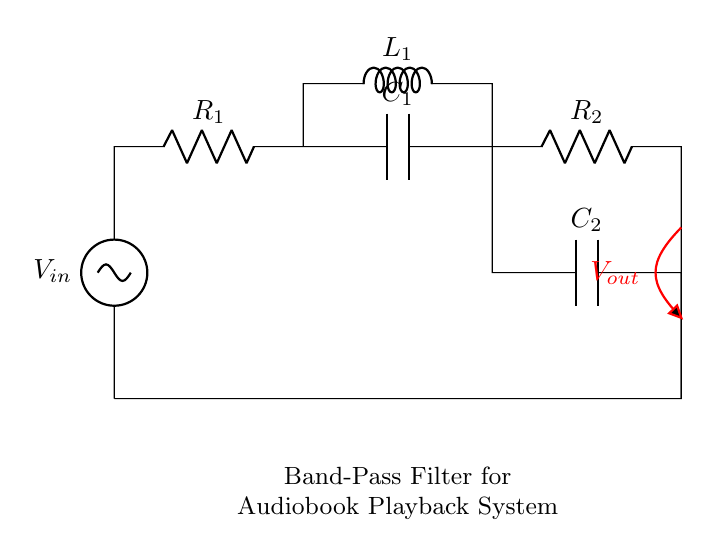What is the input voltage of the circuit? The input voltage is denoted as V_in in the circuit, which indicates the voltage supplied to the circuit.
Answer: V_in What components are connected in series with V_in? V_in is connected in series with a resistor R_1, a capacitor C_1, and a resistor R_2. These components are arranged one after the other along the same path.
Answer: R_1, C_1, R_2 Which component is connected parallel to C_1? The inductor L_1 is connected in parallel to the capacitor C_1, as indicated by the connections that allow current to flow through both elements simultaneously.
Answer: L_1 What is the purpose of this band-pass filter? The band-pass filter is designed to isolate specific frequency ranges, allowing signals within that range to pass while attenuating others, making it effective for audio applications.
Answer: Isolate specific frequency ranges What determines the center frequency of this filter? The center frequency is determined by the values of the inductor L_1 and capacitors C_1 and C_2, as these components define the filter's resonance and frequency response characteristics.
Answer: Inductor L_1 and capacitors C_1, C_2 What is the output voltage labeled as in the circuit? The output voltage in the circuit is labeled as V_out, indicating the voltage measured at the output point after the band-pass filtering process has taken place.
Answer: V_out 